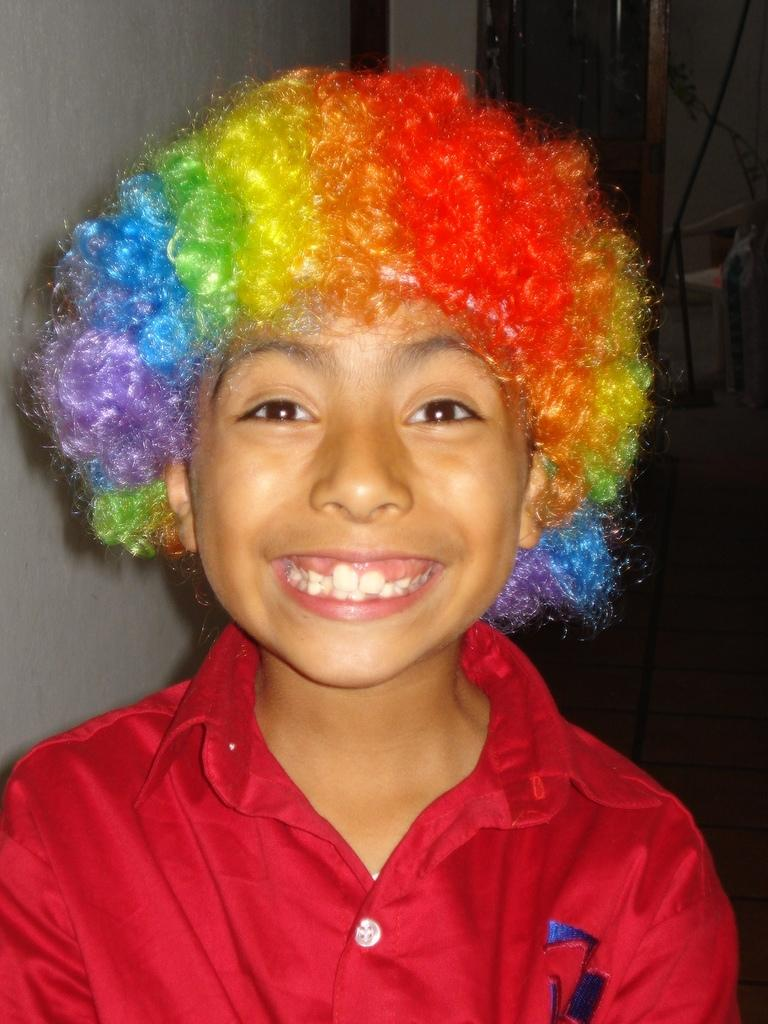What is the main subject of the image? The main subject of the image is a kid. What is the kid doing in the image? The kid is smiling in the image. What can be seen in the background of the image? There is a chair and a cable in the background of the image. Can you tell me how many goats are present in the image? There are no goats present in the image; it features a kid. In which direction is the airport located in the image? There is no airport present in the image. 